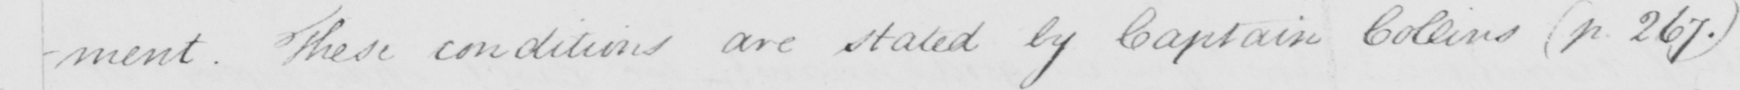What text is written in this handwritten line? -ment . These conditions are stated by Captain Collins  ( p . 267 . ) 